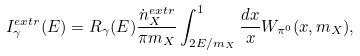Convert formula to latex. <formula><loc_0><loc_0><loc_500><loc_500>I _ { \gamma } ^ { e x t r } ( E ) = R _ { \gamma } ( E ) \frac { \dot { n } _ { X } ^ { e x t r } } { \pi m _ { X } } \int _ { 2 E / m _ { X } } ^ { 1 } \frac { d x } { x } W _ { \pi ^ { 0 } } ( x , m _ { X } ) ,</formula> 